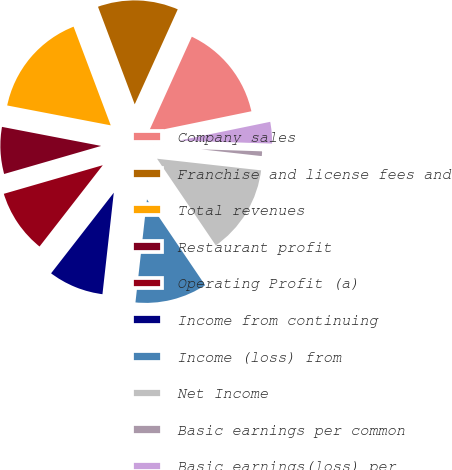Convert chart. <chart><loc_0><loc_0><loc_500><loc_500><pie_chart><fcel>Company sales<fcel>Franchise and license fees and<fcel>Total revenues<fcel>Restaurant profit<fcel>Operating Profit (a)<fcel>Income from continuing<fcel>Income (loss) from<fcel>Net Income<fcel>Basic earnings per common<fcel>Basic earnings(loss) per<nl><fcel>15.0%<fcel>12.5%<fcel>16.25%<fcel>7.5%<fcel>10.0%<fcel>8.75%<fcel>11.25%<fcel>13.75%<fcel>1.25%<fcel>3.75%<nl></chart> 